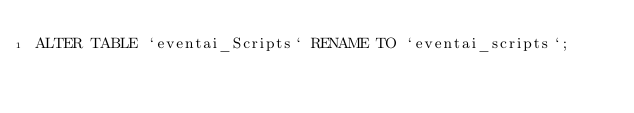Convert code to text. <code><loc_0><loc_0><loc_500><loc_500><_SQL_>ALTER TABLE `eventai_Scripts` RENAME TO `eventai_scripts`;</code> 